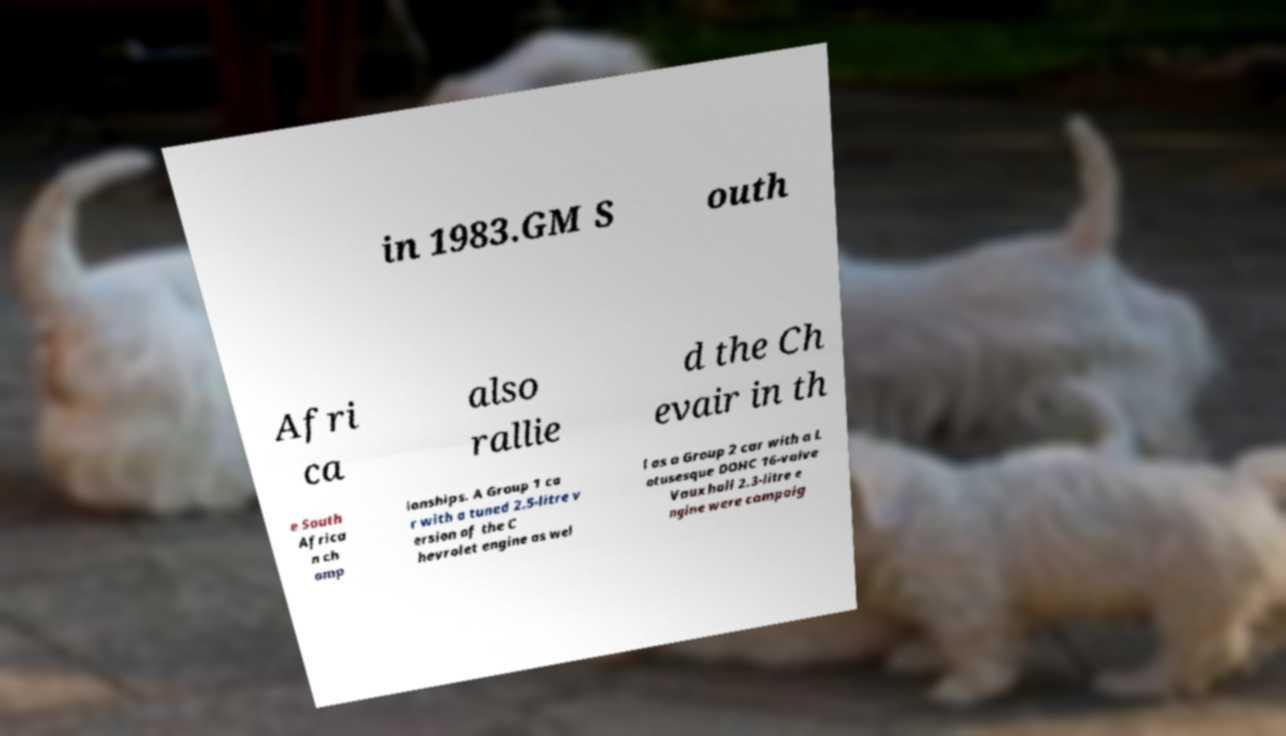Could you assist in decoding the text presented in this image and type it out clearly? in 1983.GM S outh Afri ca also rallie d the Ch evair in th e South Africa n ch amp ionships. A Group 1 ca r with a tuned 2.5-litre v ersion of the C hevrolet engine as wel l as a Group 2 car with a L otusesque DOHC 16-valve Vauxhall 2.3-litre e ngine were campaig 